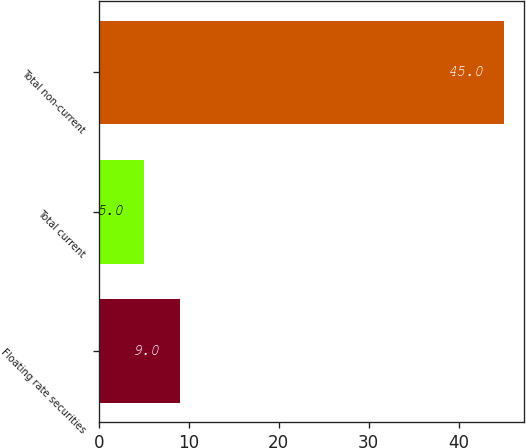Convert chart to OTSL. <chart><loc_0><loc_0><loc_500><loc_500><bar_chart><fcel>Floating rate securities<fcel>Total current<fcel>Total non-current<nl><fcel>9<fcel>5<fcel>45<nl></chart> 